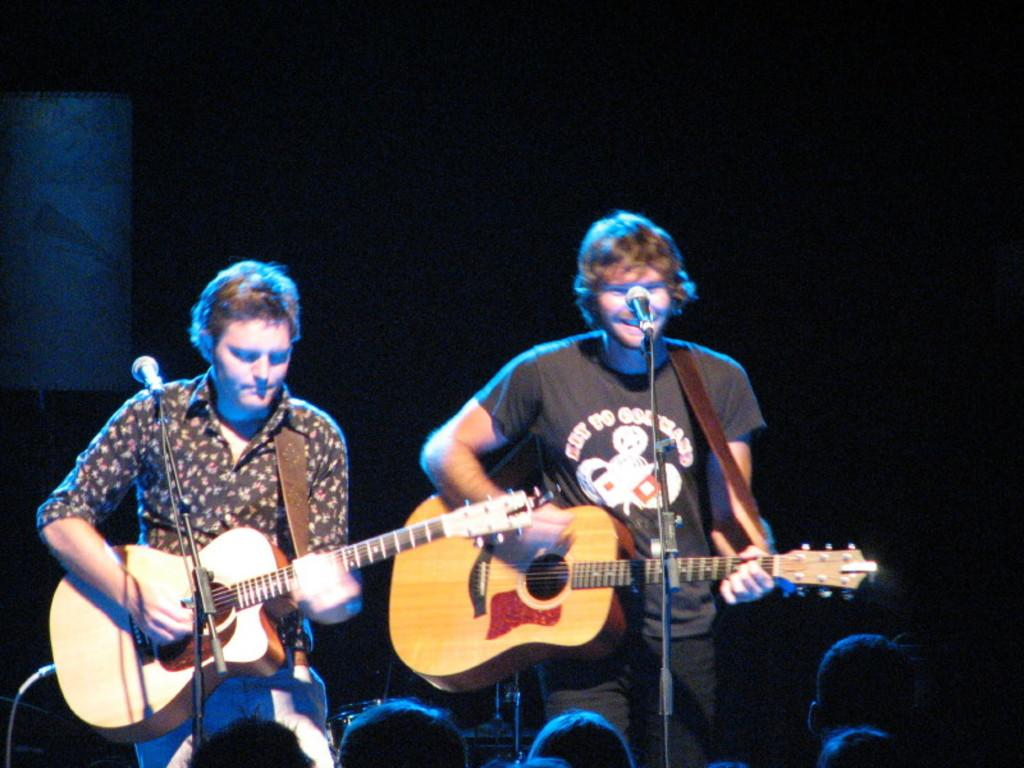How many people are in the image? There are two people in the image. What are the people doing in the image? The people are standing, and one of them is playing a guitar. The other person may also be playing a guitar or holding a microphone. What objects can be seen in the image related to music? There are microphones and a stand in the image. Are there any wires visible in the image? Yes, there are wires in the image. Can you describe the position of the people's heads in the image? Human heads are visible at the bottom of the image. What type of organization is being discussed in the image? There is no organization being discussed in the image; it features two people who may be playing music. Can you hear the person's voice in the image? The image is a still picture, so it does not contain any sound or voice. 